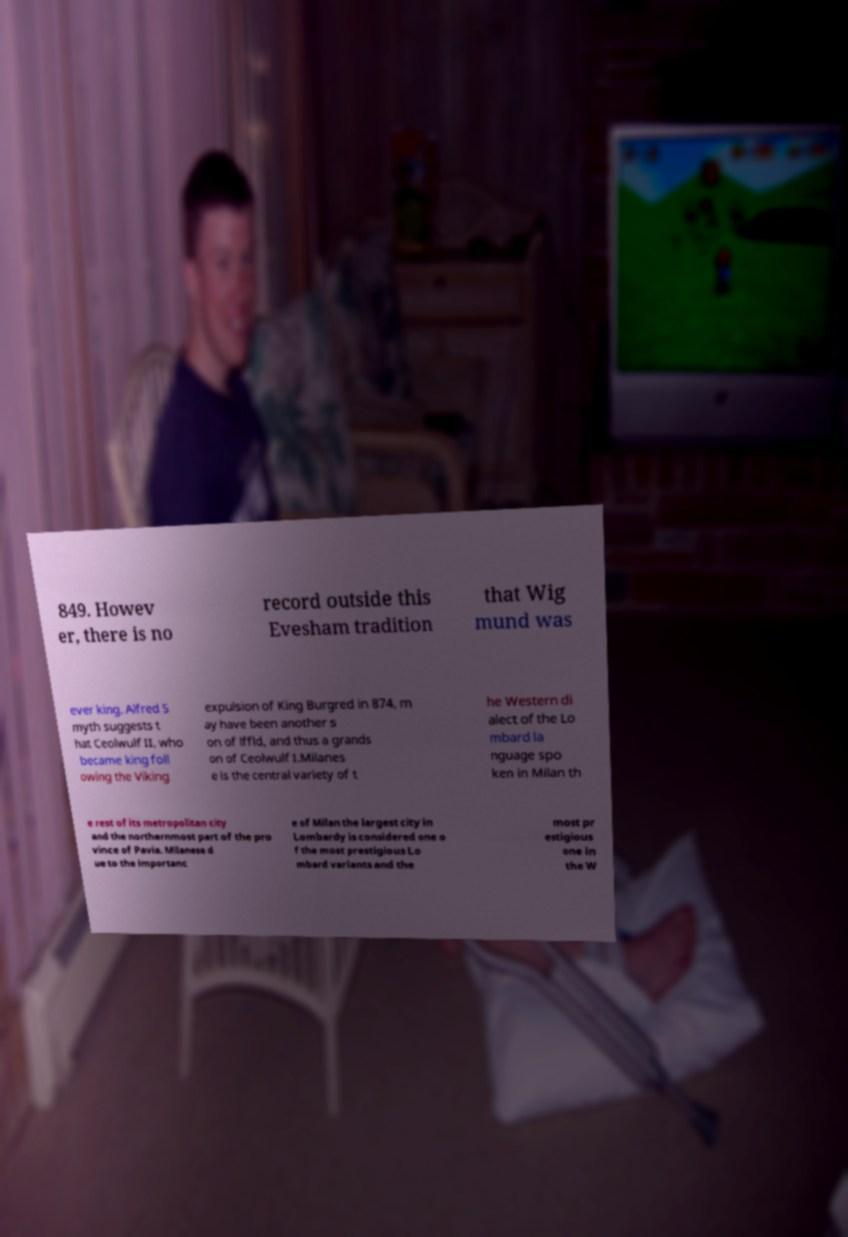Could you extract and type out the text from this image? 849. Howev er, there is no record outside this Evesham tradition that Wig mund was ever king. Alfred S myth suggests t hat Ceolwulf II, who became king foll owing the Viking expulsion of King Burgred in 874, m ay have been another s on of lffld, and thus a grands on of Ceolwulf I.Milanes e is the central variety of t he Western di alect of the Lo mbard la nguage spo ken in Milan th e rest of its metropolitan city and the northernmost part of the pro vince of Pavia. Milanese d ue to the importanc e of Milan the largest city in Lombardy is considered one o f the most prestigious Lo mbard variants and the most pr estigious one in the W 